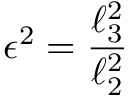Convert formula to latex. <formula><loc_0><loc_0><loc_500><loc_500>\epsilon ^ { 2 } = \frac { \ell _ { 3 } ^ { 2 } } { \ell _ { 2 } ^ { 2 } }</formula> 